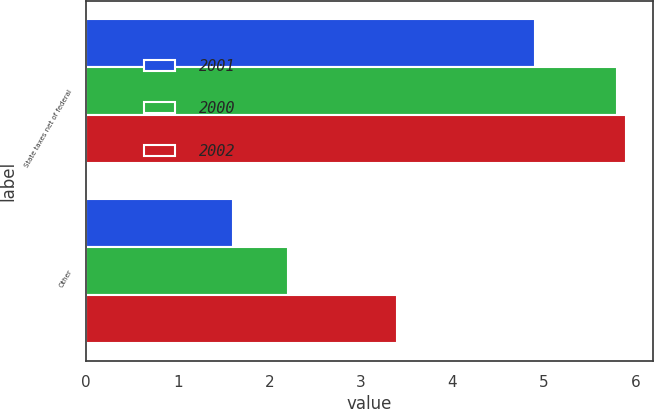Convert chart. <chart><loc_0><loc_0><loc_500><loc_500><stacked_bar_chart><ecel><fcel>State taxes net of federal<fcel>Other<nl><fcel>2001<fcel>4.9<fcel>1.6<nl><fcel>2000<fcel>5.8<fcel>2.2<nl><fcel>2002<fcel>5.9<fcel>3.4<nl></chart> 